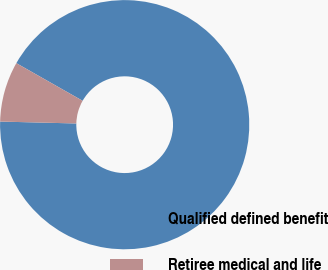Convert chart to OTSL. <chart><loc_0><loc_0><loc_500><loc_500><pie_chart><fcel>Qualified defined benefit<fcel>Retiree medical and life<nl><fcel>92.18%<fcel>7.82%<nl></chart> 